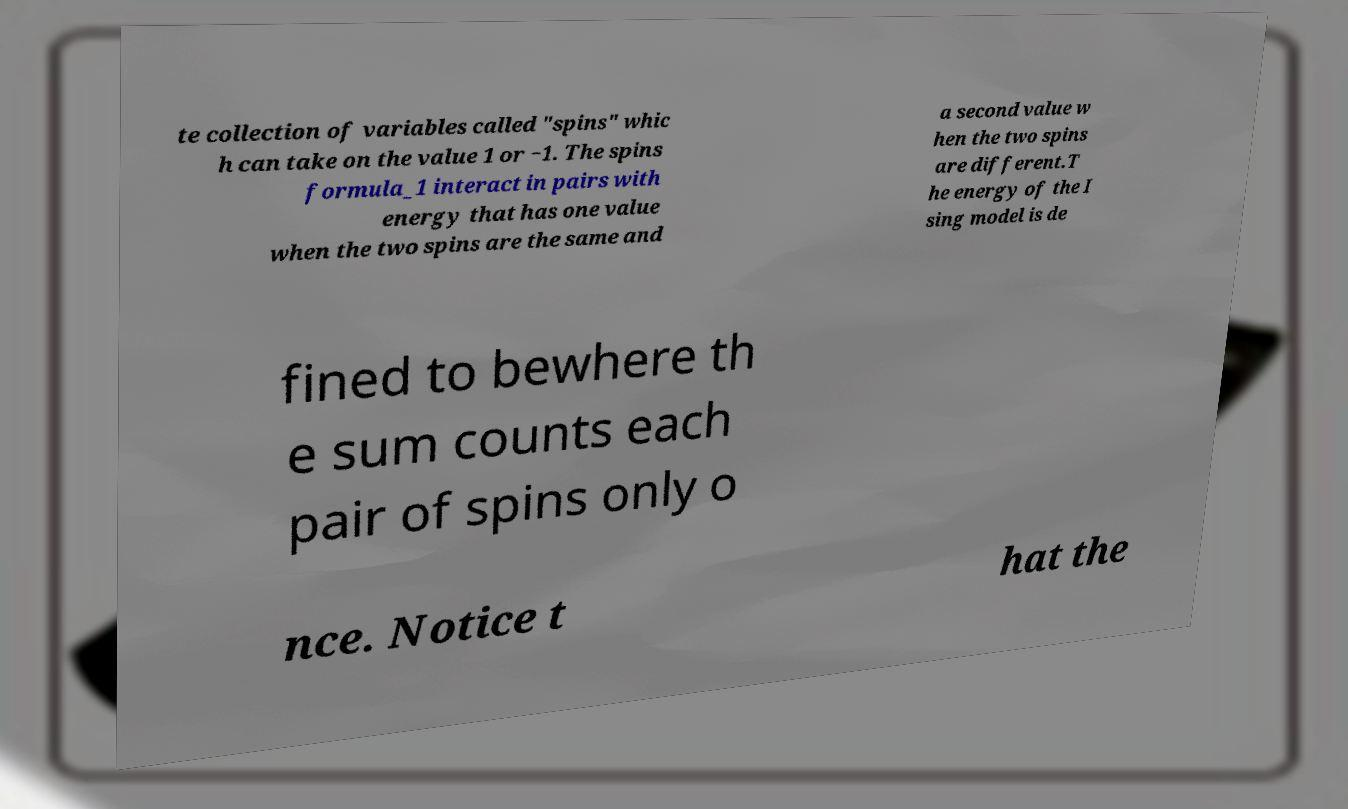Can you accurately transcribe the text from the provided image for me? te collection of variables called "spins" whic h can take on the value 1 or −1. The spins formula_1 interact in pairs with energy that has one value when the two spins are the same and a second value w hen the two spins are different.T he energy of the I sing model is de fined to bewhere th e sum counts each pair of spins only o nce. Notice t hat the 